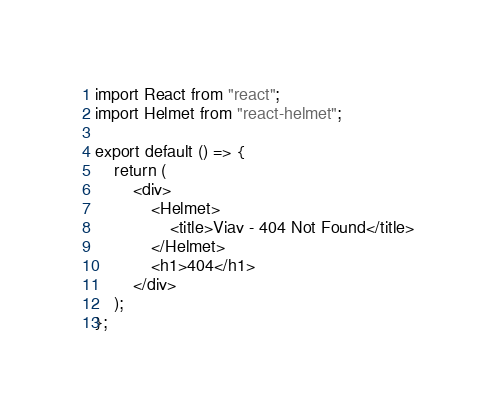Convert code to text. <code><loc_0><loc_0><loc_500><loc_500><_TypeScript_>import React from "react";
import Helmet from "react-helmet";

export default () => {
    return (
        <div>
            <Helmet>
                <title>Viav - 404 Not Found</title>
            </Helmet>
            <h1>404</h1>
        </div>
    );
};
</code> 